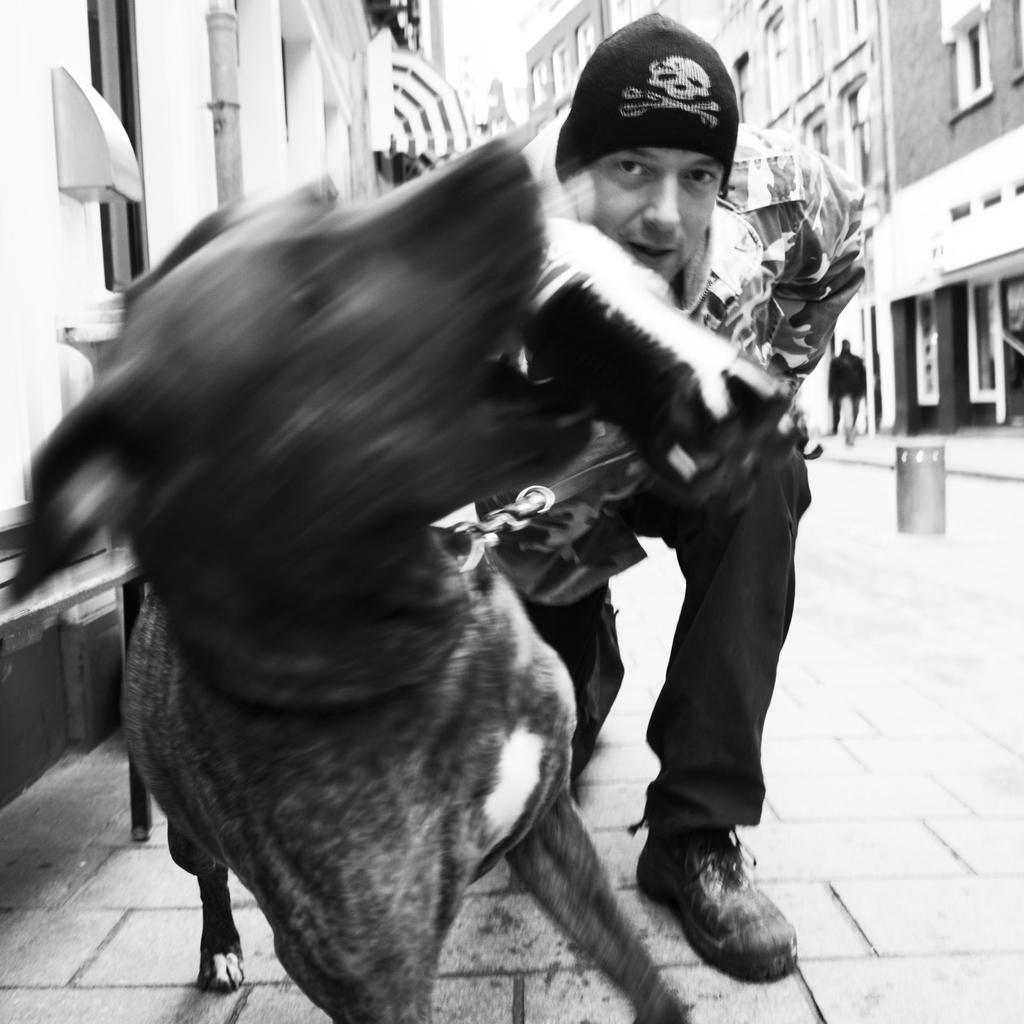Describe this image in one or two sentences. In this picture there is a man and a dog biting a bottle. In the background there is a building with windows. 